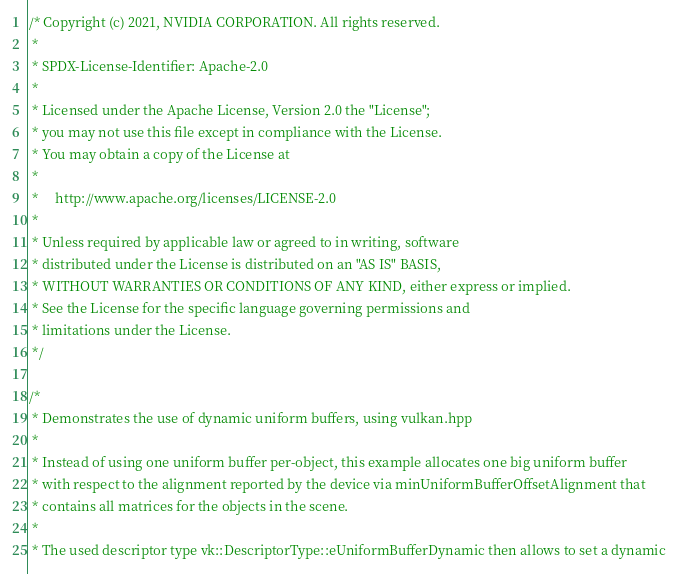<code> <loc_0><loc_0><loc_500><loc_500><_C++_>/* Copyright (c) 2021, NVIDIA CORPORATION. All rights reserved.
 *
 * SPDX-License-Identifier: Apache-2.0
 *
 * Licensed under the Apache License, Version 2.0 the "License";
 * you may not use this file except in compliance with the License.
 * You may obtain a copy of the License at
 *
 *     http://www.apache.org/licenses/LICENSE-2.0
 *
 * Unless required by applicable law or agreed to in writing, software
 * distributed under the License is distributed on an "AS IS" BASIS,
 * WITHOUT WARRANTIES OR CONDITIONS OF ANY KIND, either express or implied.
 * See the License for the specific language governing permissions and
 * limitations under the License.
 */

/*
 * Demonstrates the use of dynamic uniform buffers, using vulkan.hpp
 *
 * Instead of using one uniform buffer per-object, this example allocates one big uniform buffer
 * with respect to the alignment reported by the device via minUniformBufferOffsetAlignment that
 * contains all matrices for the objects in the scene.
 *
 * The used descriptor type vk::DescriptorType::eUniformBufferDynamic then allows to set a dynamic</code> 